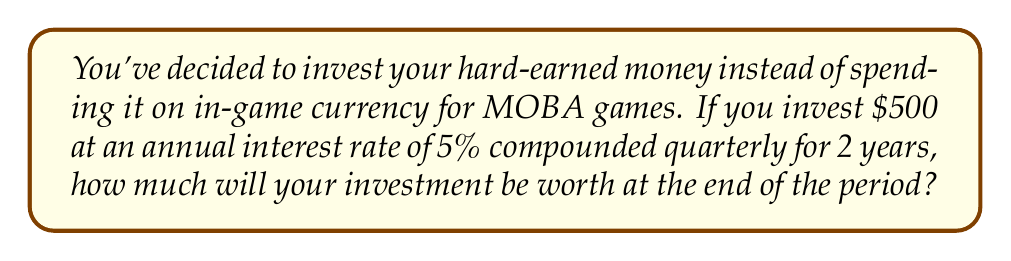Teach me how to tackle this problem. Let's approach this step-by-step using the compound interest formula:

$$A = P(1 + \frac{r}{n})^{nt}$$

Where:
$A$ = final amount
$P$ = principal (initial investment)
$r$ = annual interest rate (as a decimal)
$n$ = number of times interest is compounded per year
$t$ = number of years

Given:
$P = 500$
$r = 0.05$ (5% as a decimal)
$n = 4$ (compounded quarterly, so 4 times per year)
$t = 2$ years

Let's substitute these values into the formula:

$$A = 500(1 + \frac{0.05}{4})^{4(2)}$$

Simplify inside the parentheses:
$$A = 500(1 + 0.0125)^8$$

Calculate the power:
$$A = 500(1.0125)^8$$

Use a calculator to compute $(1.0125)^8 \approx 1.1041$:
$$A = 500(1.1041)$$

Multiply:
$$A = 552.05$$
Answer: $552.05 